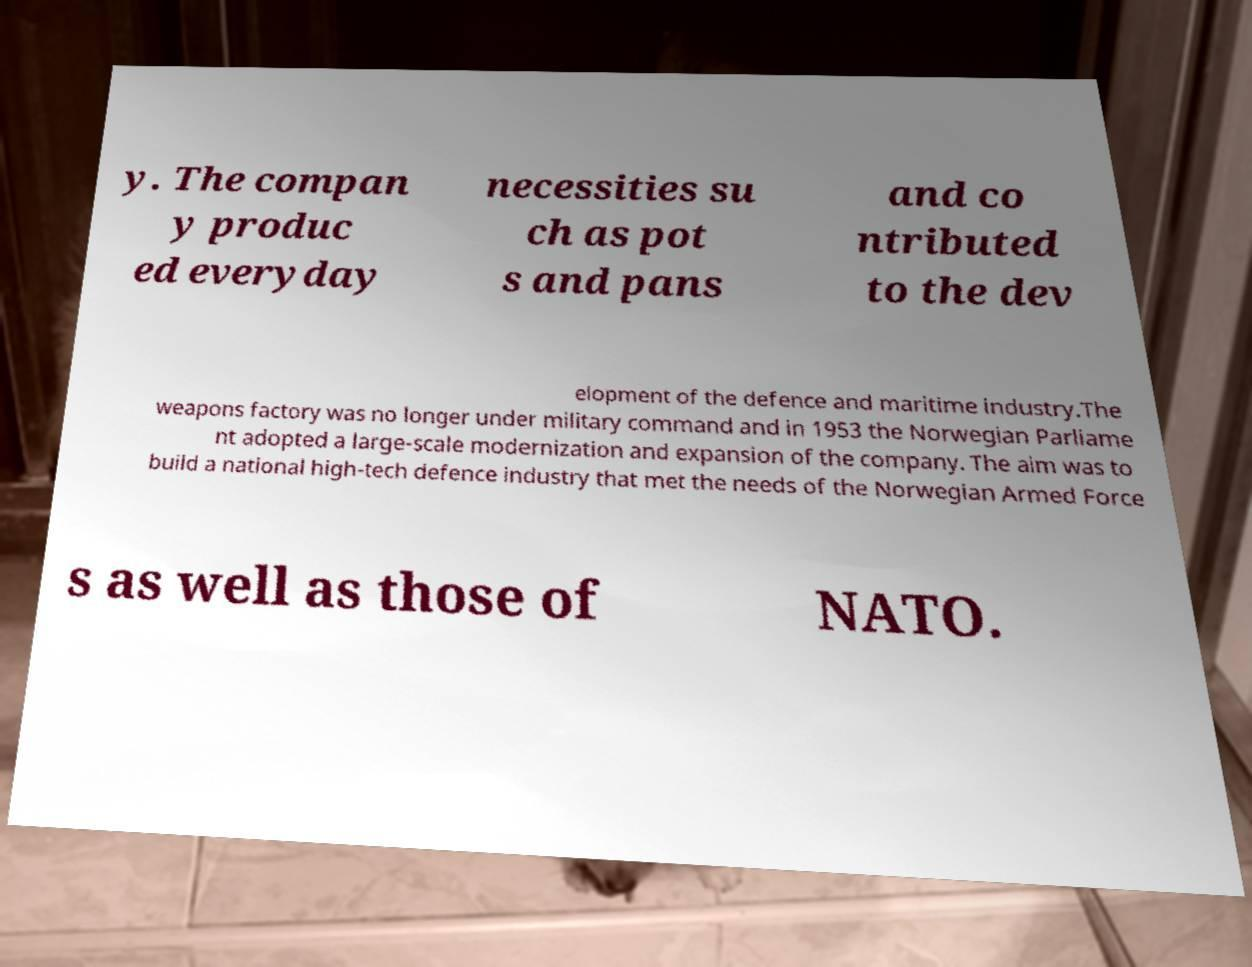What messages or text are displayed in this image? I need them in a readable, typed format. y. The compan y produc ed everyday necessities su ch as pot s and pans and co ntributed to the dev elopment of the defence and maritime industry.The weapons factory was no longer under military command and in 1953 the Norwegian Parliame nt adopted a large-scale modernization and expansion of the company. The aim was to build a national high-tech defence industry that met the needs of the Norwegian Armed Force s as well as those of NATO. 